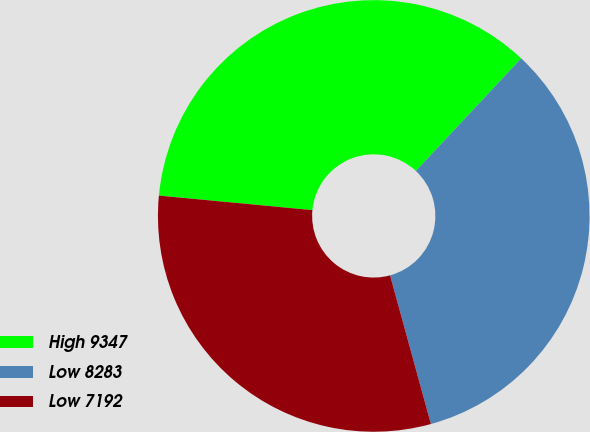<chart> <loc_0><loc_0><loc_500><loc_500><pie_chart><fcel>High 9347<fcel>Low 8283<fcel>Low 7192<nl><fcel>35.47%<fcel>33.76%<fcel>30.77%<nl></chart> 